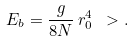Convert formula to latex. <formula><loc_0><loc_0><loc_500><loc_500>E _ { b } = \frac { g } { 8 N } \, r _ { 0 } ^ { 4 } \ > .</formula> 